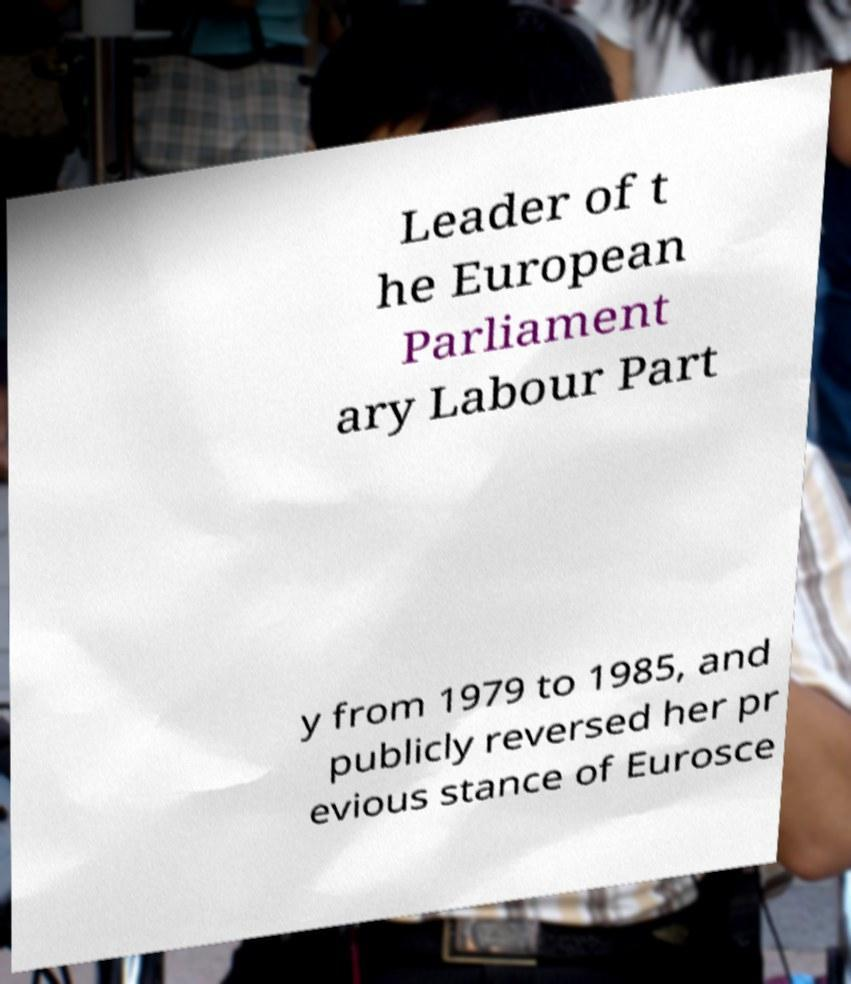Can you read and provide the text displayed in the image?This photo seems to have some interesting text. Can you extract and type it out for me? Leader of t he European Parliament ary Labour Part y from 1979 to 1985, and publicly reversed her pr evious stance of Eurosce 